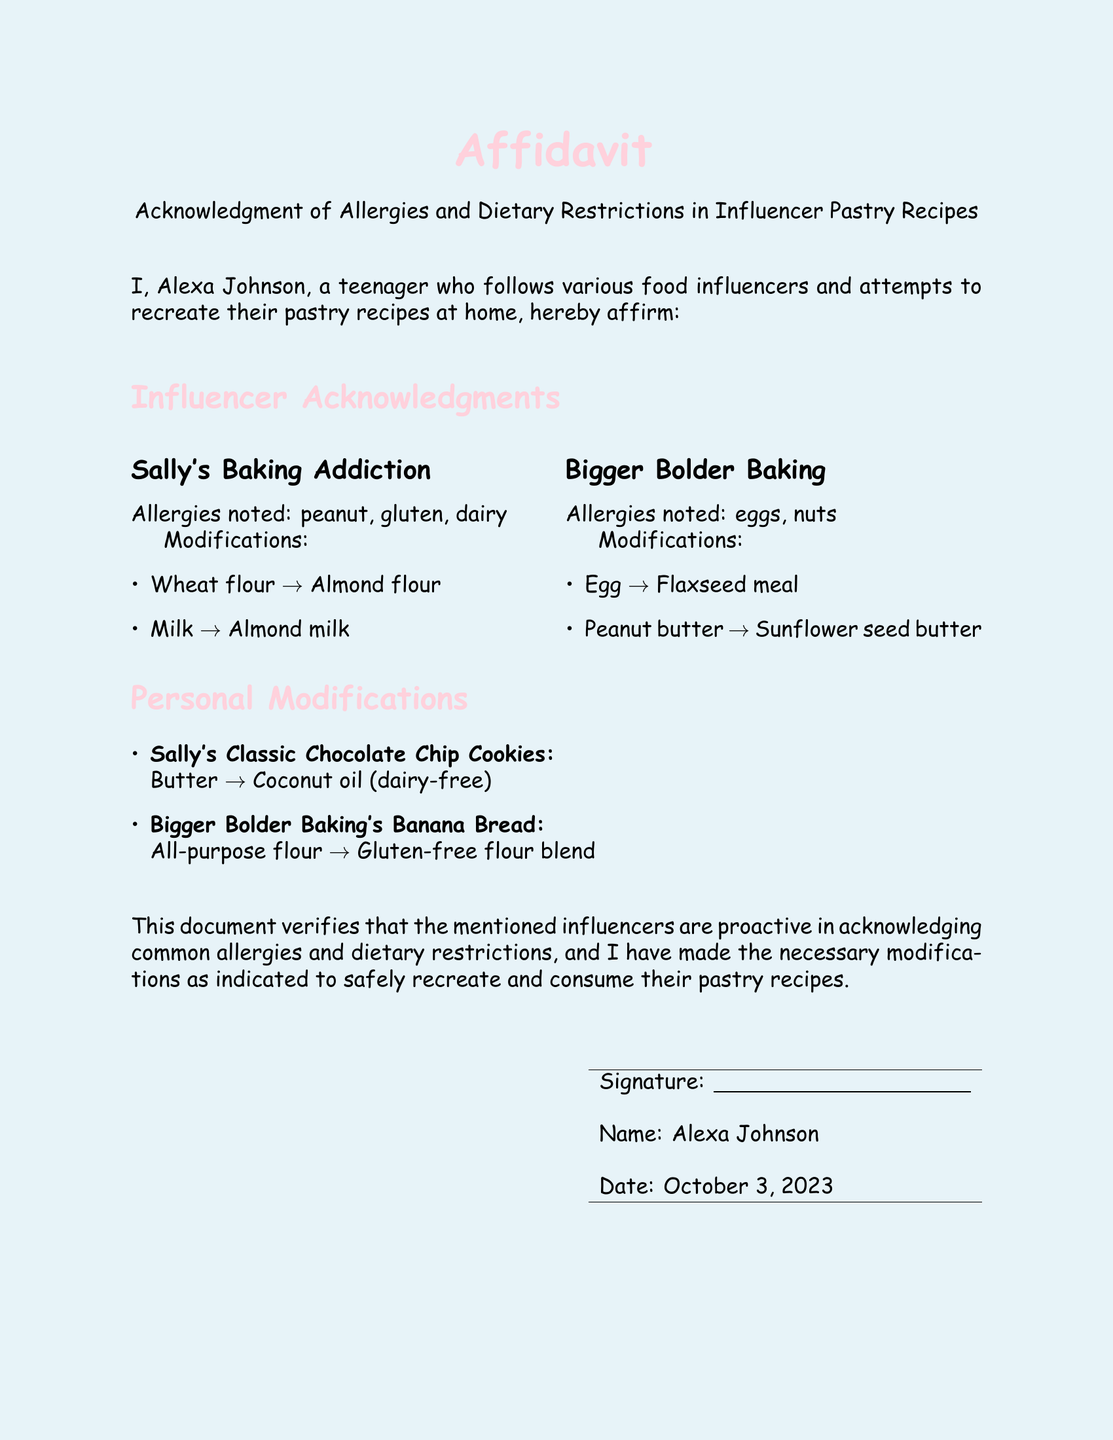What is the teenager's name? The document states the teenager's name as "Alexa Johnson."
Answer: Alexa Johnson What date was the affidavit signed? The date indicated in the affidavit is "October 3, 2023."
Answer: October 3, 2023 What allergy is noted for Sally's Baking Addiction? The affidavit lists "peanut" as one of the allergies noted for Sally's Baking Addiction.
Answer: peanut What ingredient was swapped for dairy-free butter? The document shows "coconut oil" was used as a substitute for butter.
Answer: coconut oil Which alternative replaces eggs in Bigger Bolder Baking's recipes? The affidavit mentions "flaxseed meal" as the modification for eggs.
Answer: flaxseed meal How many influencers' recipes are addressed in the document? The affidavit includes recipes from "two" influencers: Sally's Baking Addiction and Bigger Bolder Baking.
Answer: two What type of flour is used in the personal modification for banana bread? The document states that "gluten-free flour blend" is used in place of all-purpose flour for banana bread.
Answer: gluten-free flour blend Is the document a signed affidavit? The document is labeled as an "Affidavit" at the beginning.
Answer: Yes What is the primary purpose of the affidavit? The affidavit verifies modifications made for safe consumption considering allergies and dietary restrictions.
Answer: Acknowledgment of allergies and dietary restrictions 